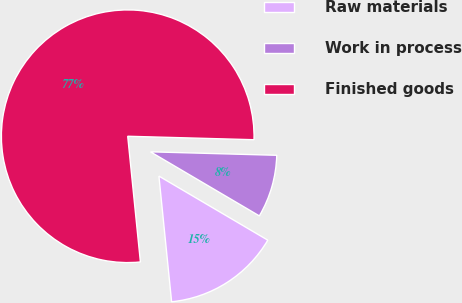Convert chart to OTSL. <chart><loc_0><loc_0><loc_500><loc_500><pie_chart><fcel>Raw materials<fcel>Work in process<fcel>Finished goods<nl><fcel>14.93%<fcel>8.03%<fcel>77.04%<nl></chart> 